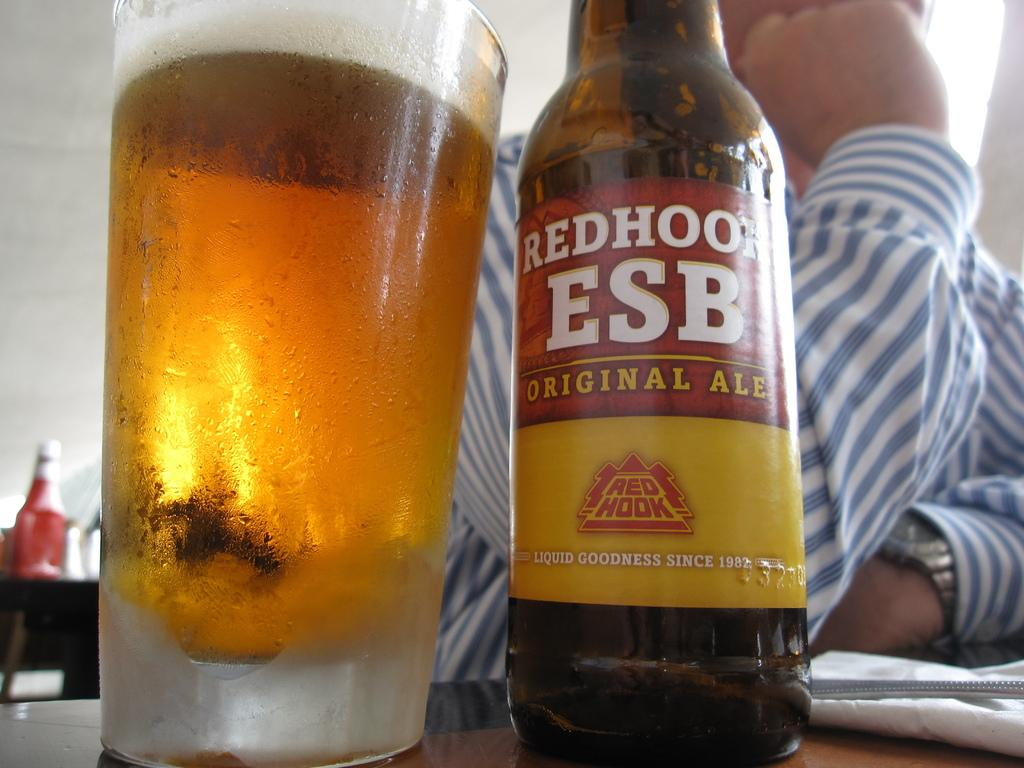<image>
Give a short and clear explanation of the subsequent image. A bottle of  orginal ale sitting next to a cold glass filled with the ale, a man is sitting behind it. 